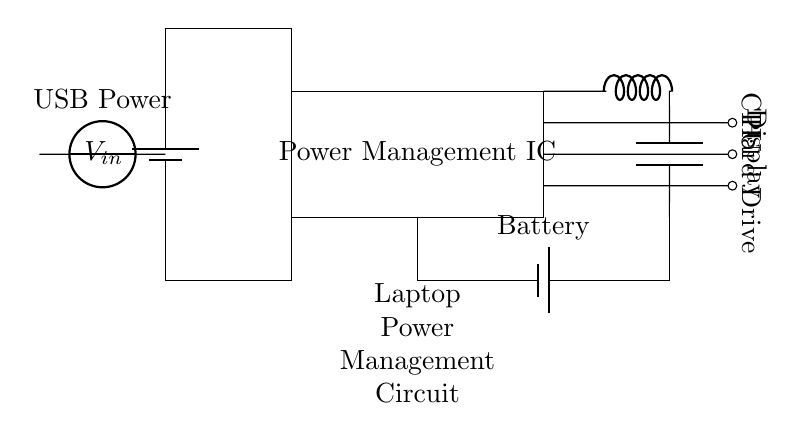What is the input voltage to the circuit? The input voltage can be identified from the battery symbol labeled as \( V_{in} \), which represents the supplied voltage.
Answer: \( V_{in} \) What components are powered by the power management IC? The circuit diagram shows three outputs from the power management IC: one to the CPU, one to the Display, and one to the Hard Drive, indicating these components receive power from it.
Answer: CPU, Display, Hard Drive What is the purpose of the USB power connection? The USB power connection indicates that there is an additional source of power available for the circuit, which can be used to charge the laptop's battery or power the laptop directly.
Answer: Additional power source How does the battery integrate into the circuit? The battery is incorporated as both a power source and a storage element that can charge when the circuit receives input voltage. It supplies power when the laptop is not connected to an external source.
Answer: Power source and storage What type of component is the cute inductor connected to? The cute inductor is connected to an output path that includes a capacitor, which suggests it serves a filtering or smoothing function in association with voltage regulation for the output to laptop components.
Answer: Capacitor How does power flow from the battery to the laptop components? Power flows from the battery, through the power management IC, and is subsequently directed to the CPU, Display, and Hard Drive, facilitating their operation.
Answer: Through power management IC Which part of the circuit is responsible for voltage regulation? The voltage regulation is handled by the cute inductor connected in series with the capacitor, serving to stabilize the voltage supplied to the output components.
Answer: Cute inductor and capacitor 